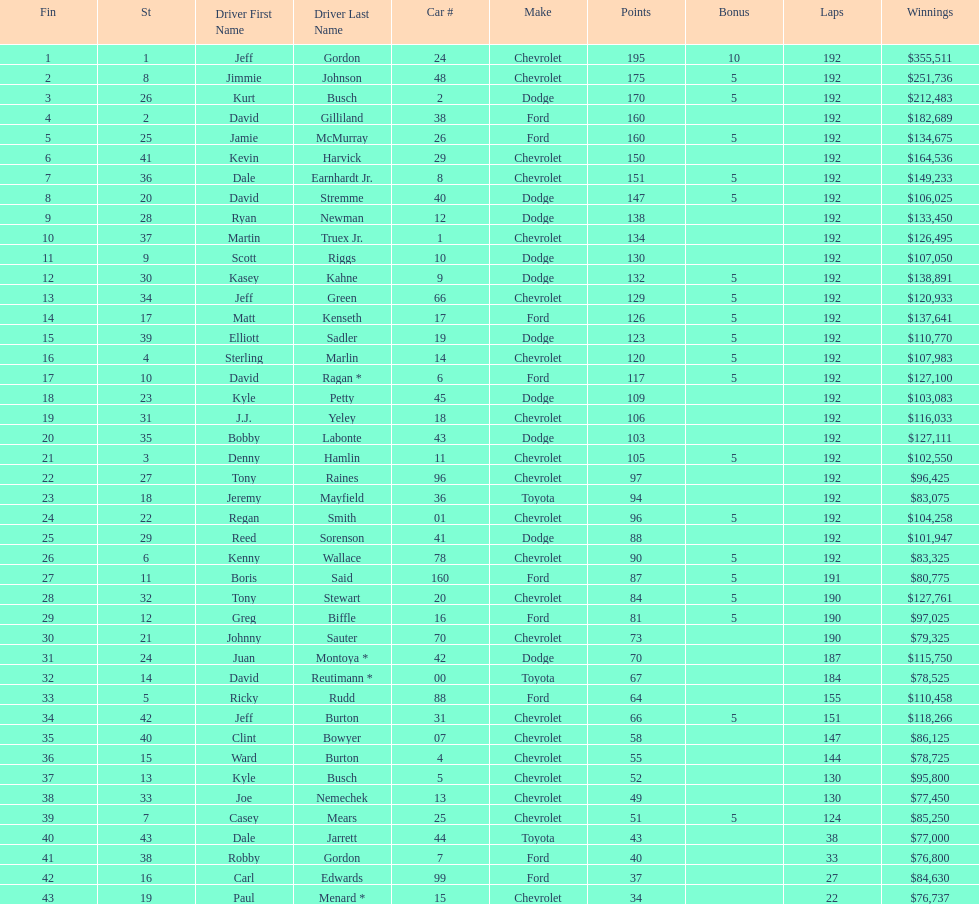What was the make of both jeff gordon's and jimmie johnson's race car? Chevrolet. 